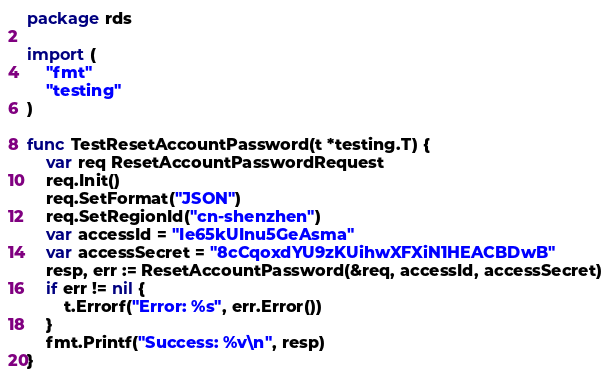Convert code to text. <code><loc_0><loc_0><loc_500><loc_500><_Go_>package rds

import (
	"fmt"
	"testing"
)

func TestResetAccountPassword(t *testing.T) {
	var req ResetAccountPasswordRequest
	req.Init()
	req.SetFormat("JSON")
	req.SetRegionId("cn-shenzhen")
	var accessId = "Ie65kUInu5GeAsma"
	var accessSecret = "8cCqoxdYU9zKUihwXFXiN1HEACBDwB"
	resp, err := ResetAccountPassword(&req, accessId, accessSecret)
	if err != nil {
		t.Errorf("Error: %s", err.Error())
	}
	fmt.Printf("Success: %v\n", resp)
}
</code> 